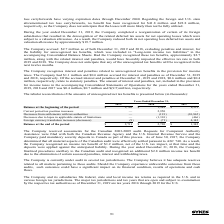According to Sykes Enterprises Incorporated's financial document, What was the Balance at the end of the period in 2019? According to the financial document, $2,711 (in thousands). The relevant text states: "Balance at the end of the period $ 2,711 $ 2,720 $ 1,342..." Also, What was the Balance at the beginning of the period in 2018? According to the financial document, $1,342 (in thousands). The relevant text states: "Balance at the beginning of the period $ 2,720 $ 1,342 $ 8,531..." Also, For which years were the tabular reconciliation of the amounts of unrecognized net tax benefits calculated? The document contains multiple relevant values: 2019, 2018, 2017. From the document: "s for the years ended December 31, 2019, 2018 and 2017 was $0.4 million, $0.7 million and $(9.5) million, respectively. ued for interest and penalties..." Additionally, In which year was the Balance at the end of the period the largest? According to the financial document, 2018. The relevant text states: "nterest and penalties as of December 31, 2019 and 2018, respectively. Of the accrued interest and penalties at December 31, 2019 and 2018, $0.6 million an..." Also, can you calculate: What was the change in the Balance at the end of the period in 2019 from 2018? Based on the calculation: 2,711-2,720, the result is -9 (in thousands). This is based on the information: "Balance at the end of the period $ 2,711 $ 2,720 $ 1,342 Balance at the beginning of the period $ 2,720 $ 1,342 $ 8,531..." The key data points involved are: 2,711, 2,720. Also, can you calculate: What was the percentage change in the Balance at the end of the period in 2019 from 2018? To answer this question, I need to perform calculations using the financial data. The calculation is: (2,711-2,720)/2,720, which equals -0.33 (percentage). This is based on the information: "Balance at the end of the period $ 2,711 $ 2,720 $ 1,342 Balance at the beginning of the period $ 2,720 $ 1,342 $ 8,531..." The key data points involved are: 2,711, 2,720. 